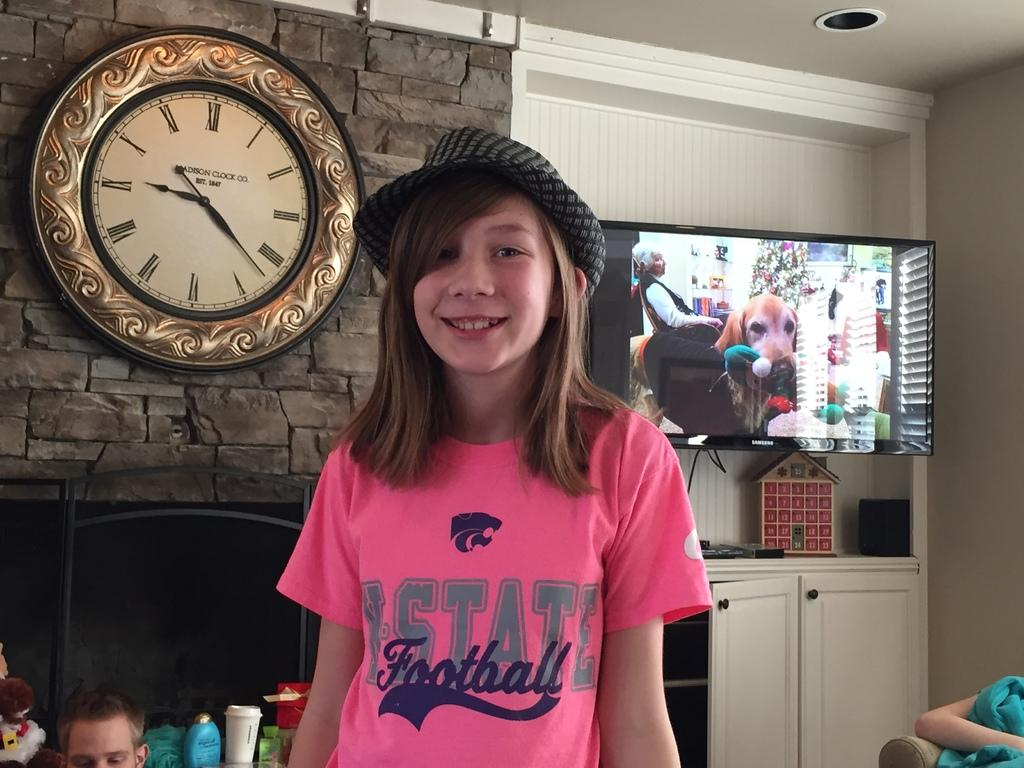<image>
Give a short and clear explanation of the subsequent image. A girl in a K-State Football shirt stands in a living room. 